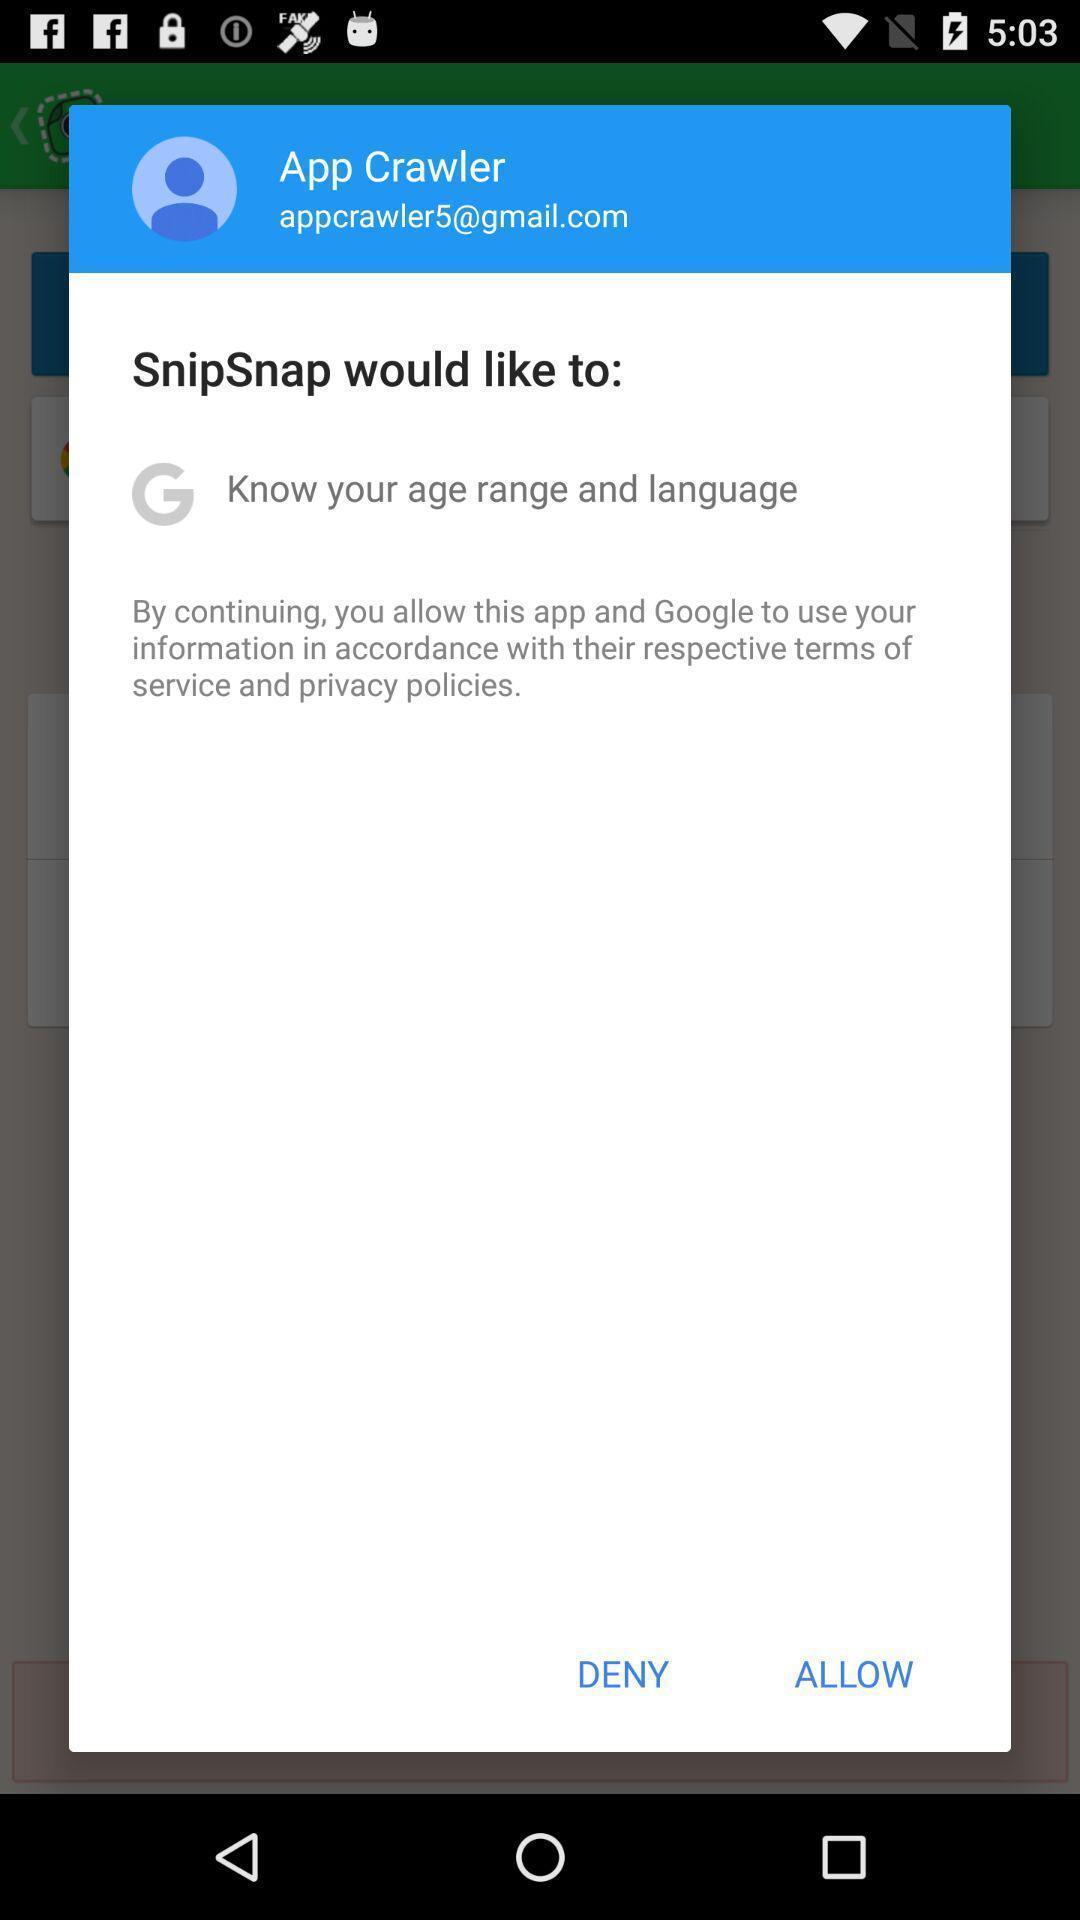Summarize the information in this screenshot. Pop up asking to deny or allow the app. 